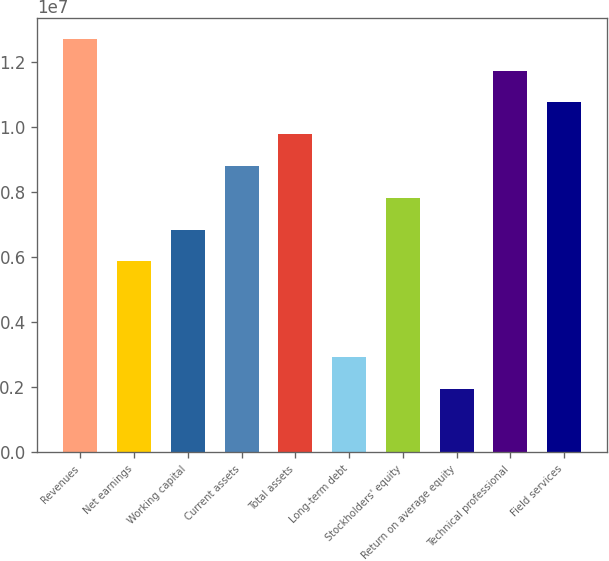Convert chart. <chart><loc_0><loc_0><loc_500><loc_500><bar_chart><fcel>Revenues<fcel>Net earnings<fcel>Working capital<fcel>Current assets<fcel>Total assets<fcel>Long-term debt<fcel>Stockholders' equity<fcel>Return on average equity<fcel>Technical professional<fcel>Field services<nl><fcel>1.2711e+07<fcel>5.86662e+06<fcel>6.84439e+06<fcel>8.79993e+06<fcel>9.7777e+06<fcel>2.93331e+06<fcel>7.82216e+06<fcel>1.95554e+06<fcel>1.17332e+07<fcel>1.07555e+07<nl></chart> 